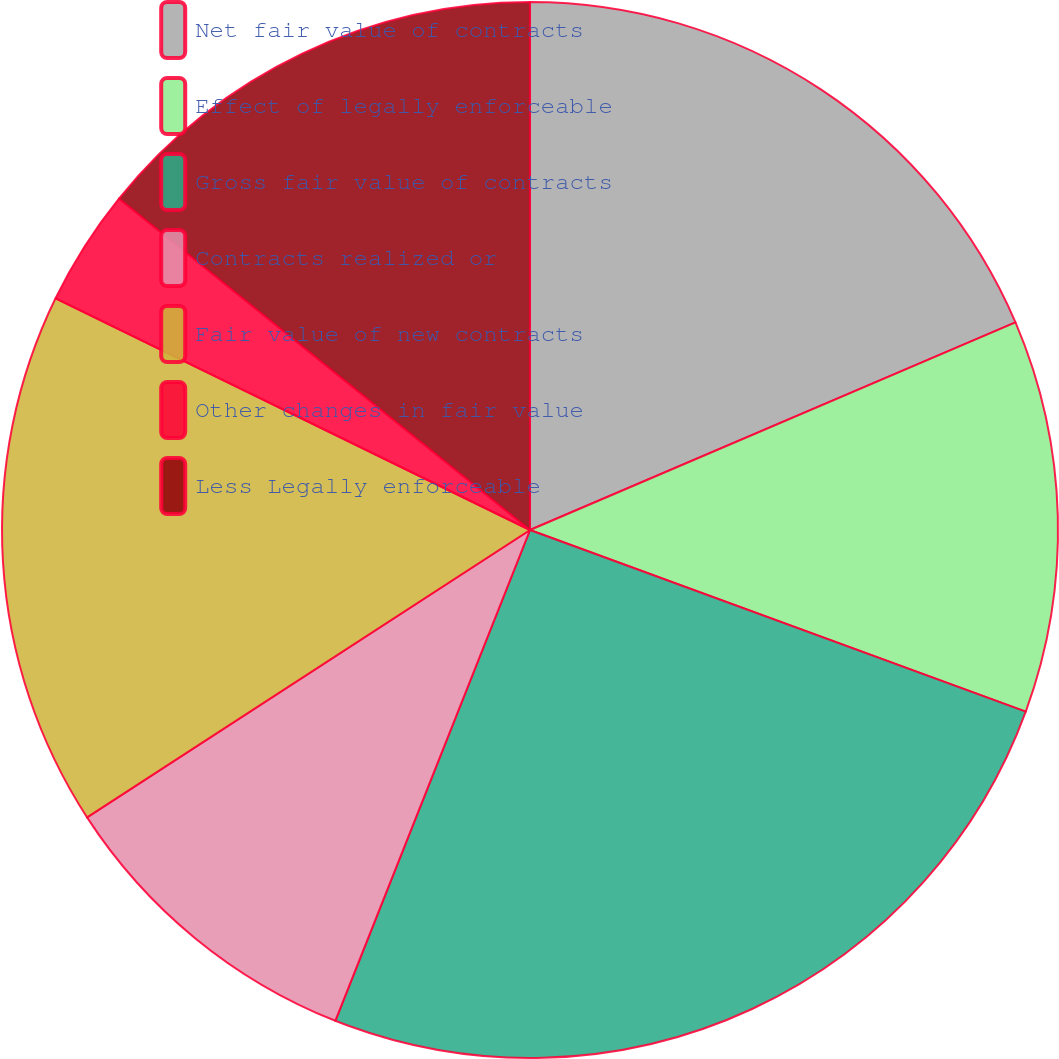Convert chart. <chart><loc_0><loc_0><loc_500><loc_500><pie_chart><fcel>Net fair value of contracts<fcel>Effect of legally enforceable<fcel>Gross fair value of contracts<fcel>Contracts realized or<fcel>Fair value of new contracts<fcel>Other changes in fair value<fcel>Less Legally enforceable<nl><fcel>18.57%<fcel>12.02%<fcel>25.42%<fcel>9.83%<fcel>16.39%<fcel>3.57%<fcel>14.2%<nl></chart> 